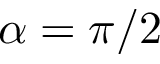Convert formula to latex. <formula><loc_0><loc_0><loc_500><loc_500>\alpha = \pi / 2</formula> 